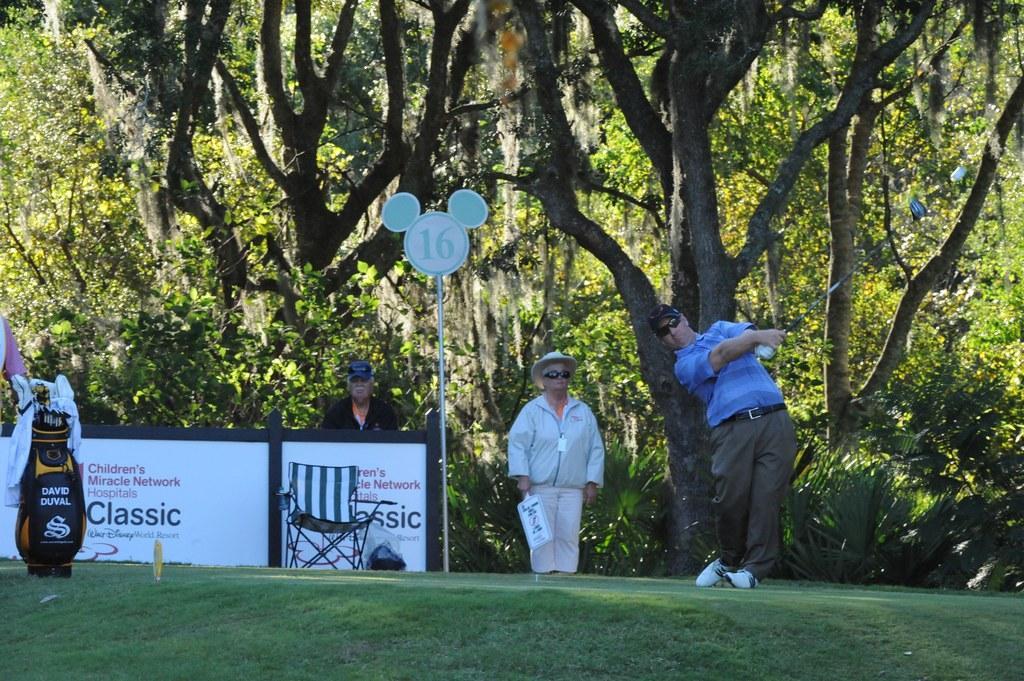In one or two sentences, can you explain what this image depicts? In this image we can see group of persons standing on the ground. Two persons are wearing goggles. One person is holding a golf stick in his hand. In the center of the image we can see a signboard on a pole, chair placed on the ground, a board with some text. To the left side of the image we can see a bag placed on the ground. In the background, we can see a group of trees. 